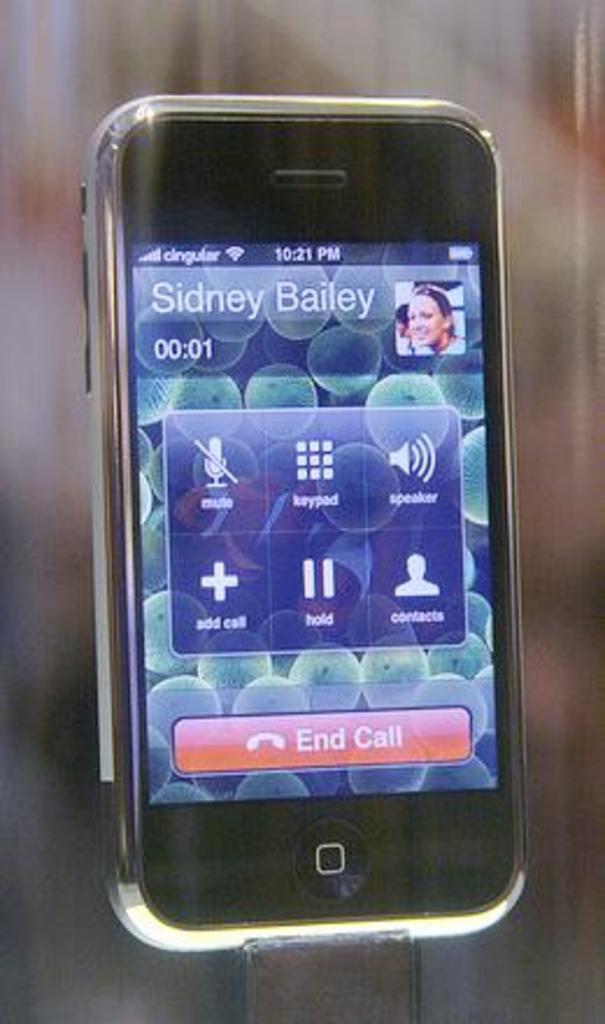What is the carrier of the phone?
Provide a succinct answer. Cingular. What time does the phone say?
Your answer should be very brief. 10:21 pm. 